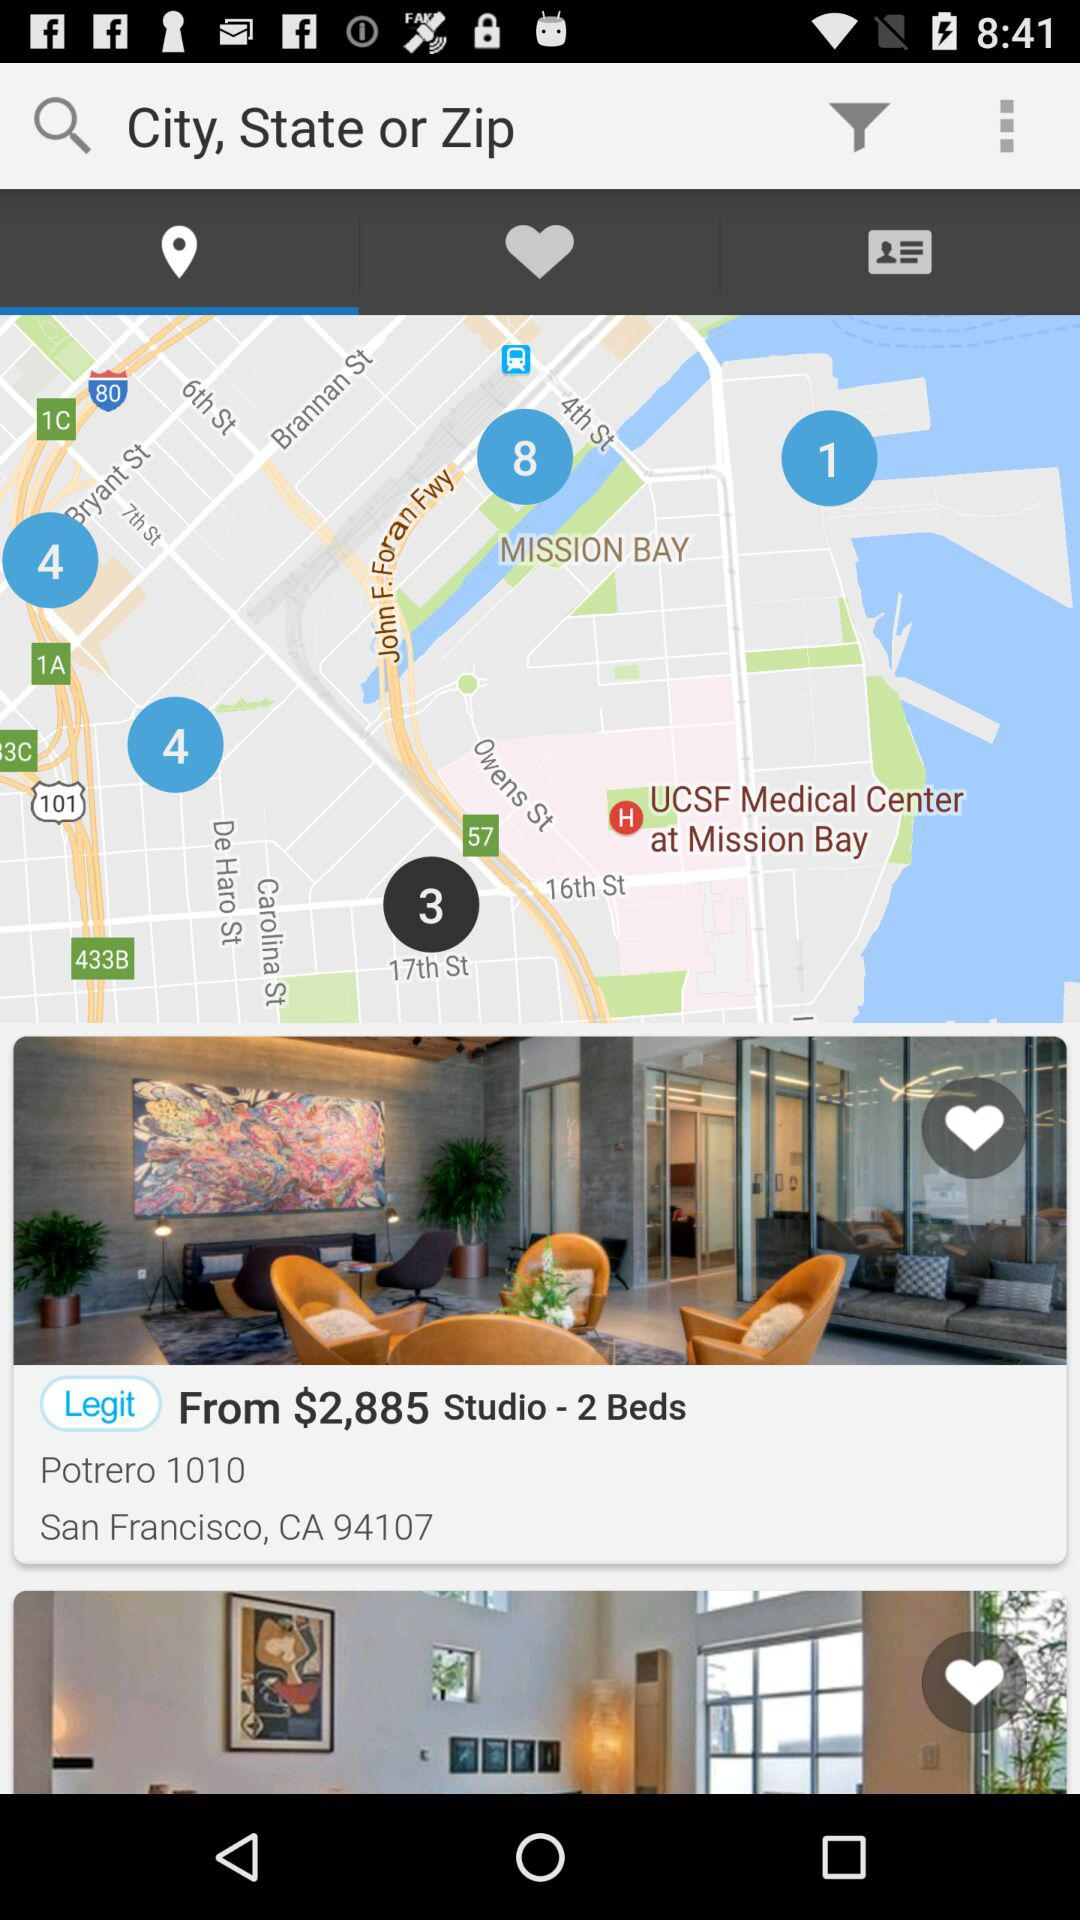How many beds are available? The number of available beds is 2. 